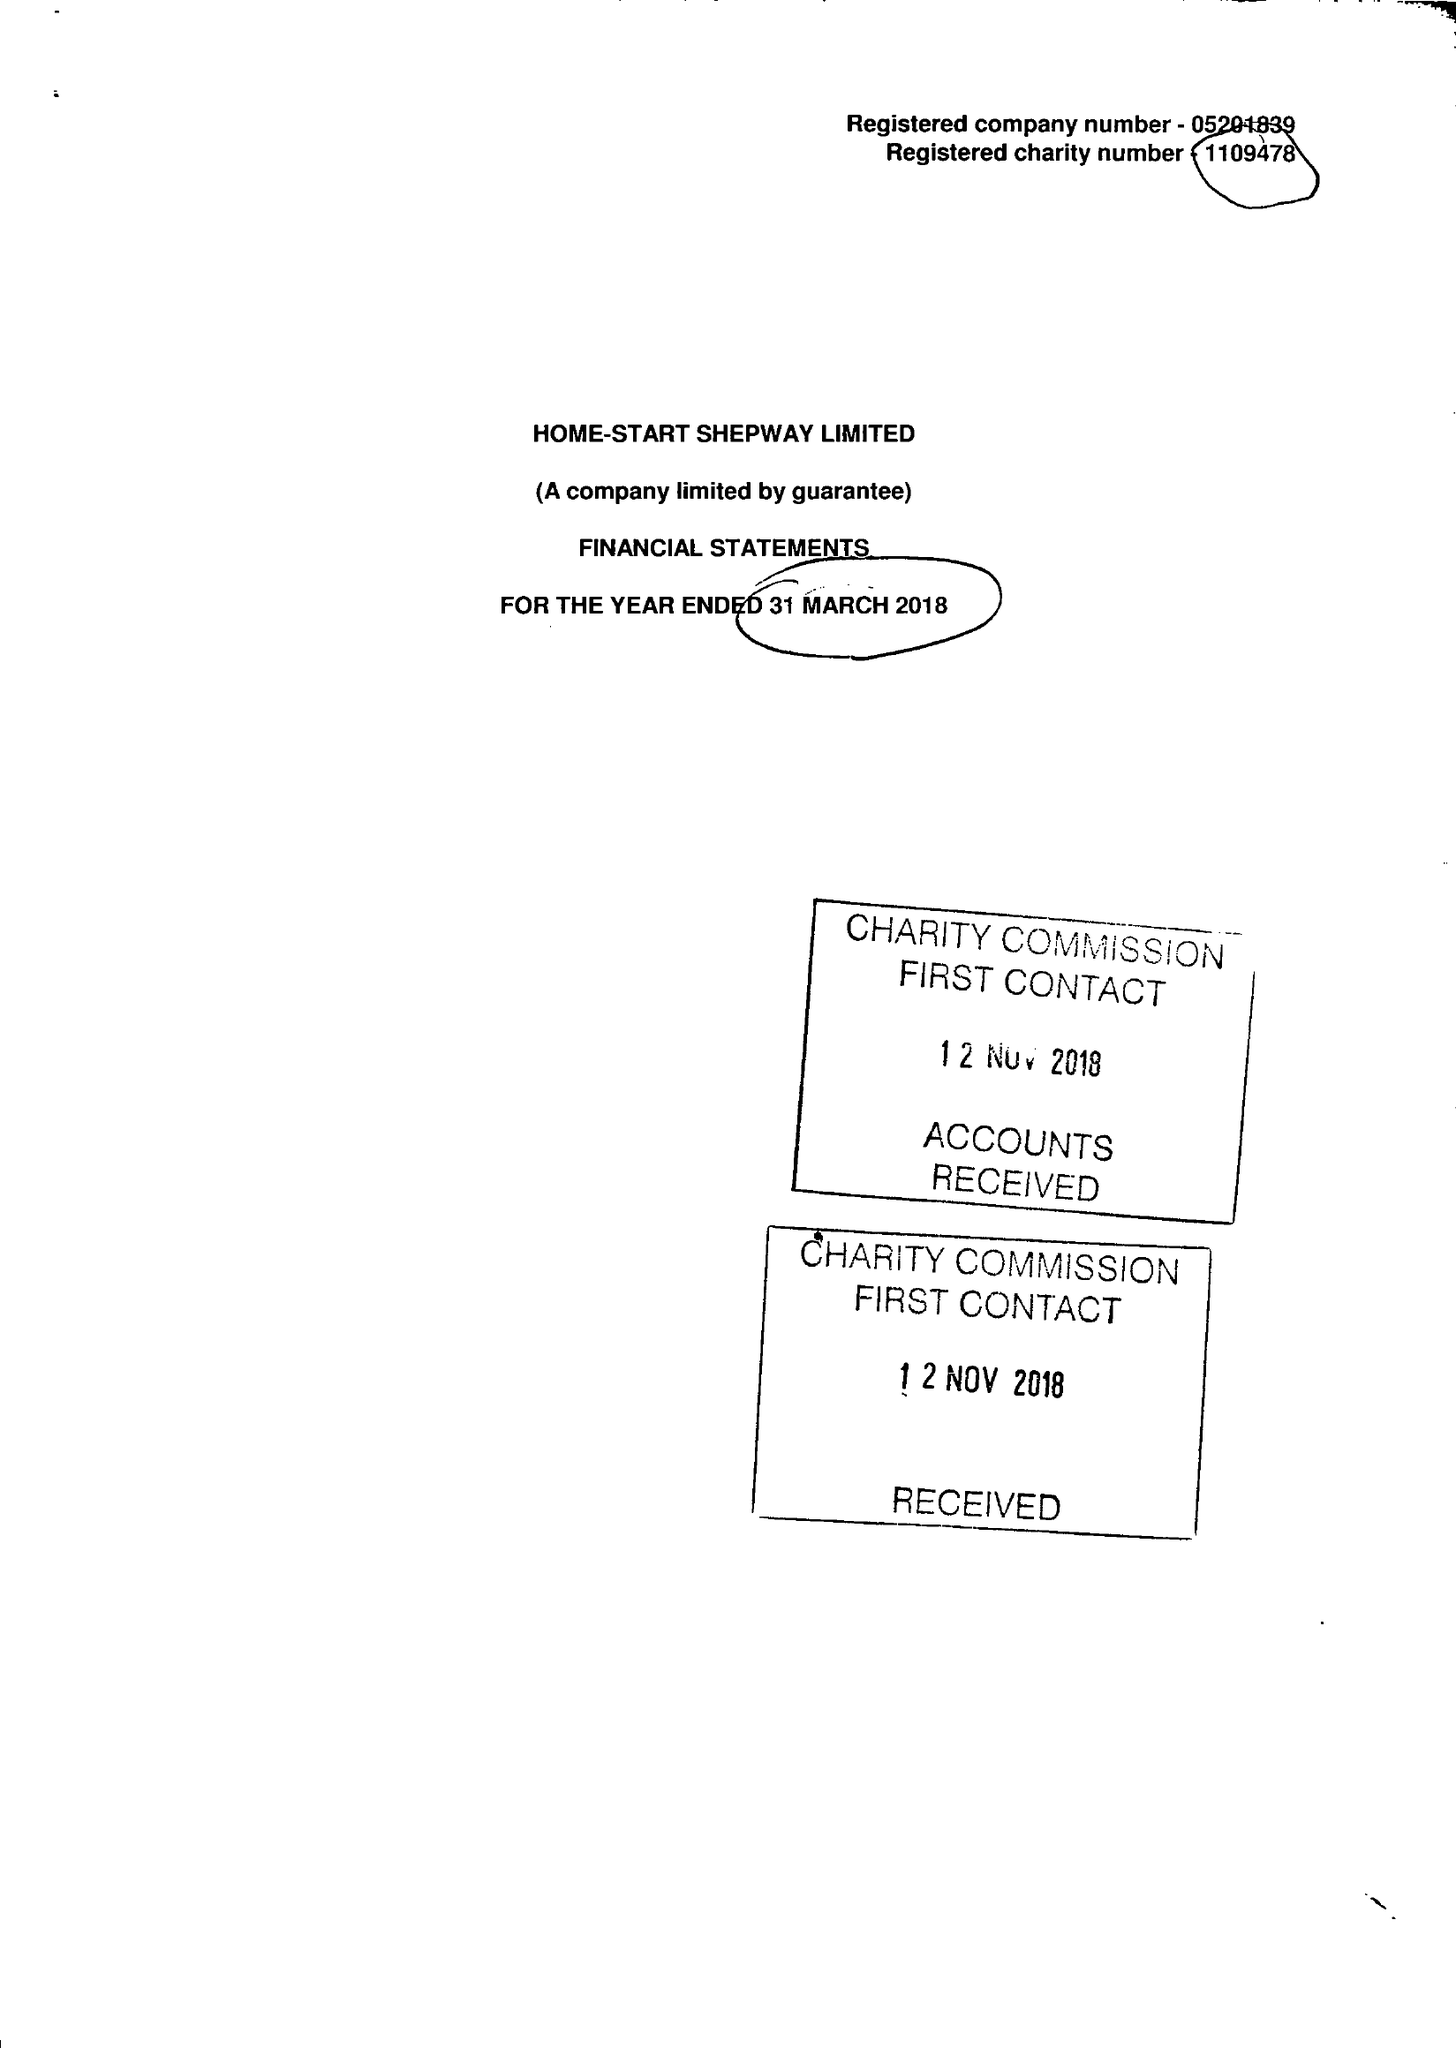What is the value for the charity_name?
Answer the question using a single word or phrase. Home-Start Shepway Ltd. 